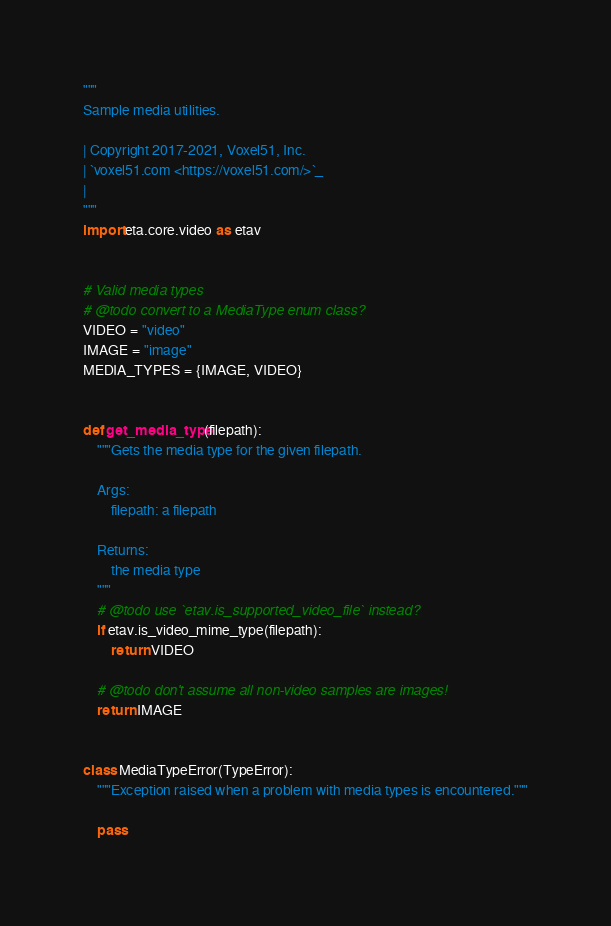Convert code to text. <code><loc_0><loc_0><loc_500><loc_500><_Python_>"""
Sample media utilities.

| Copyright 2017-2021, Voxel51, Inc.
| `voxel51.com <https://voxel51.com/>`_
|
"""
import eta.core.video as etav


# Valid media types
# @todo convert to a MediaType enum class?
VIDEO = "video"
IMAGE = "image"
MEDIA_TYPES = {IMAGE, VIDEO}


def get_media_type(filepath):
    """Gets the media type for the given filepath.

    Args:
        filepath: a filepath

    Returns:
        the media type
    """
    # @todo use `etav.is_supported_video_file` instead?
    if etav.is_video_mime_type(filepath):
        return VIDEO

    # @todo don't assume all non-video samples are images!
    return IMAGE


class MediaTypeError(TypeError):
    """Exception raised when a problem with media types is encountered."""

    pass
</code> 